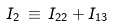Convert formula to latex. <formula><loc_0><loc_0><loc_500><loc_500>I _ { 2 } \, \equiv \, I _ { 2 2 } + I _ { 1 3 }</formula> 